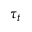<formula> <loc_0><loc_0><loc_500><loc_500>\tau _ { t }</formula> 